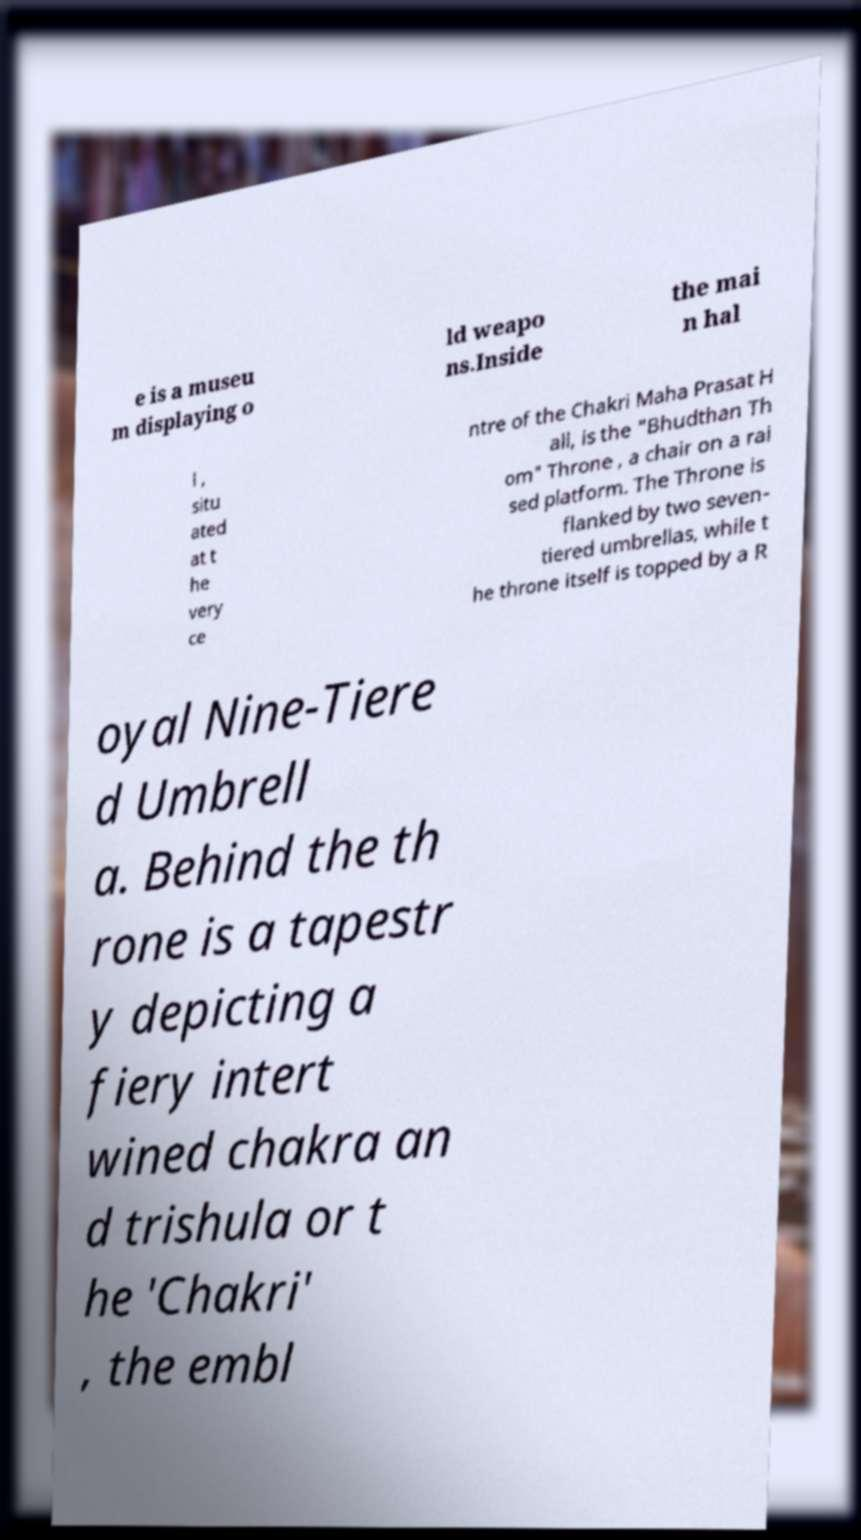There's text embedded in this image that I need extracted. Can you transcribe it verbatim? e is a museu m displaying o ld weapo ns.Inside the mai n hal l , situ ated at t he very ce ntre of the Chakri Maha Prasat H all, is the "Bhudthan Th om" Throne , a chair on a rai sed platform. The Throne is flanked by two seven- tiered umbrellas, while t he throne itself is topped by a R oyal Nine-Tiere d Umbrell a. Behind the th rone is a tapestr y depicting a fiery intert wined chakra an d trishula or t he 'Chakri' , the embl 